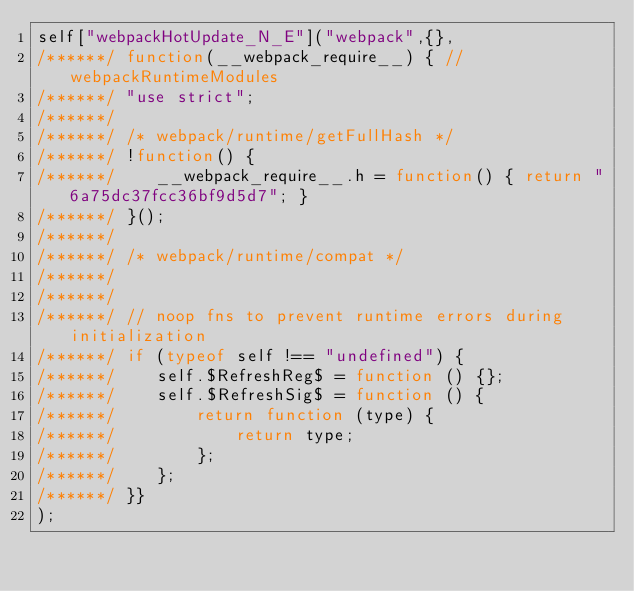Convert code to text. <code><loc_0><loc_0><loc_500><loc_500><_JavaScript_>self["webpackHotUpdate_N_E"]("webpack",{},
/******/ function(__webpack_require__) { // webpackRuntimeModules
/******/ "use strict";
/******/ 
/******/ /* webpack/runtime/getFullHash */
/******/ !function() {
/******/ 	__webpack_require__.h = function() { return "6a75dc37fcc36bf9d5d7"; }
/******/ }();
/******/ 
/******/ /* webpack/runtime/compat */
/******/ 
/******/ 
/******/ // noop fns to prevent runtime errors during initialization
/******/ if (typeof self !== "undefined") {
/******/ 	self.$RefreshReg$ = function () {};
/******/ 	self.$RefreshSig$ = function () {
/******/ 		return function (type) {
/******/ 			return type;
/******/ 		};
/******/ 	};
/******/ }}
);</code> 